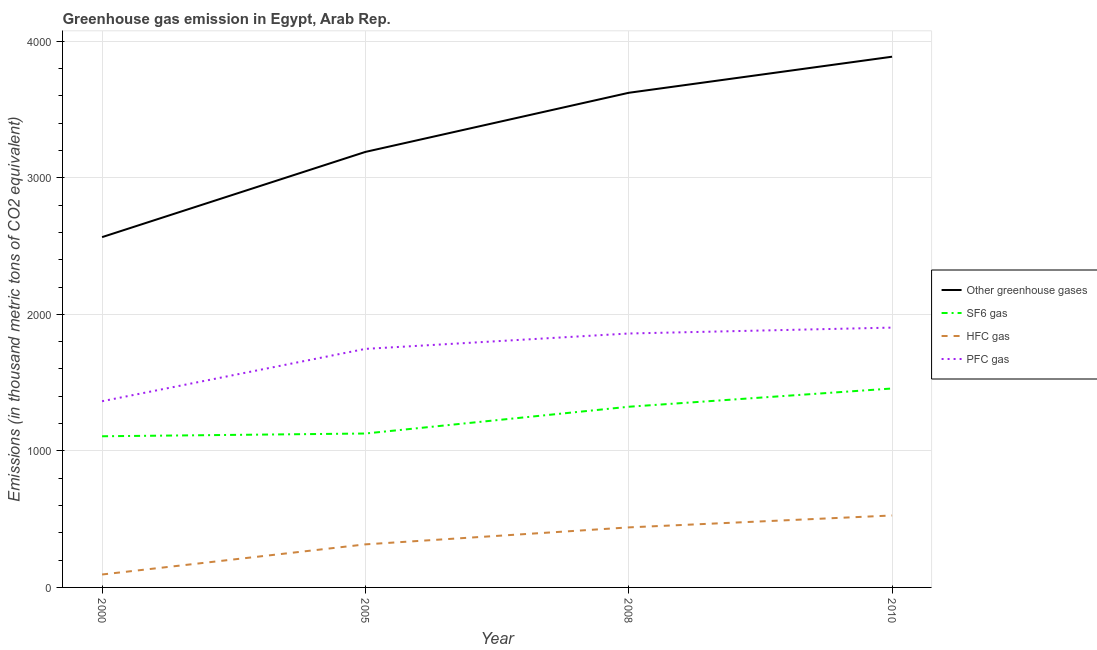Does the line corresponding to emission of pfc gas intersect with the line corresponding to emission of sf6 gas?
Your answer should be very brief. No. Is the number of lines equal to the number of legend labels?
Make the answer very short. Yes. What is the emission of hfc gas in 2000?
Give a very brief answer. 94.7. Across all years, what is the maximum emission of sf6 gas?
Make the answer very short. 1457. Across all years, what is the minimum emission of pfc gas?
Offer a terse response. 1363.8. In which year was the emission of pfc gas maximum?
Offer a very short reply. 2010. In which year was the emission of pfc gas minimum?
Your response must be concise. 2000. What is the total emission of hfc gas in the graph?
Offer a very short reply. 1376.8. What is the difference between the emission of pfc gas in 2000 and that in 2005?
Give a very brief answer. -383.3. What is the difference between the emission of pfc gas in 2010 and the emission of sf6 gas in 2008?
Ensure brevity in your answer.  579.7. What is the average emission of pfc gas per year?
Provide a succinct answer. 1718.42. In the year 2000, what is the difference between the emission of greenhouse gases and emission of pfc gas?
Your response must be concise. 1201.8. In how many years, is the emission of hfc gas greater than 600 thousand metric tons?
Your response must be concise. 0. What is the ratio of the emission of greenhouse gases in 2005 to that in 2010?
Make the answer very short. 0.82. Is the emission of sf6 gas in 2008 less than that in 2010?
Give a very brief answer. Yes. What is the difference between the highest and the second highest emission of hfc gas?
Make the answer very short. 87.3. What is the difference between the highest and the lowest emission of pfc gas?
Offer a very short reply. 539.2. Is the sum of the emission of hfc gas in 2000 and 2010 greater than the maximum emission of greenhouse gases across all years?
Make the answer very short. No. Is it the case that in every year, the sum of the emission of greenhouse gases and emission of sf6 gas is greater than the emission of hfc gas?
Provide a succinct answer. Yes. Is the emission of greenhouse gases strictly greater than the emission of sf6 gas over the years?
Offer a very short reply. Yes. What is the difference between two consecutive major ticks on the Y-axis?
Make the answer very short. 1000. Does the graph contain any zero values?
Provide a short and direct response. No. What is the title of the graph?
Your response must be concise. Greenhouse gas emission in Egypt, Arab Rep. What is the label or title of the Y-axis?
Your response must be concise. Emissions (in thousand metric tons of CO2 equivalent). What is the Emissions (in thousand metric tons of CO2 equivalent) of Other greenhouse gases in 2000?
Keep it short and to the point. 2565.6. What is the Emissions (in thousand metric tons of CO2 equivalent) of SF6 gas in 2000?
Give a very brief answer. 1107.1. What is the Emissions (in thousand metric tons of CO2 equivalent) of HFC gas in 2000?
Make the answer very short. 94.7. What is the Emissions (in thousand metric tons of CO2 equivalent) of PFC gas in 2000?
Offer a terse response. 1363.8. What is the Emissions (in thousand metric tons of CO2 equivalent) of Other greenhouse gases in 2005?
Your answer should be very brief. 3189.8. What is the Emissions (in thousand metric tons of CO2 equivalent) of SF6 gas in 2005?
Provide a short and direct response. 1127.3. What is the Emissions (in thousand metric tons of CO2 equivalent) in HFC gas in 2005?
Your answer should be compact. 315.4. What is the Emissions (in thousand metric tons of CO2 equivalent) of PFC gas in 2005?
Ensure brevity in your answer.  1747.1. What is the Emissions (in thousand metric tons of CO2 equivalent) of Other greenhouse gases in 2008?
Your answer should be compact. 3622.8. What is the Emissions (in thousand metric tons of CO2 equivalent) in SF6 gas in 2008?
Give a very brief answer. 1323.3. What is the Emissions (in thousand metric tons of CO2 equivalent) in HFC gas in 2008?
Offer a very short reply. 439.7. What is the Emissions (in thousand metric tons of CO2 equivalent) in PFC gas in 2008?
Offer a very short reply. 1859.8. What is the Emissions (in thousand metric tons of CO2 equivalent) of Other greenhouse gases in 2010?
Your response must be concise. 3887. What is the Emissions (in thousand metric tons of CO2 equivalent) in SF6 gas in 2010?
Your answer should be compact. 1457. What is the Emissions (in thousand metric tons of CO2 equivalent) of HFC gas in 2010?
Your response must be concise. 527. What is the Emissions (in thousand metric tons of CO2 equivalent) in PFC gas in 2010?
Provide a succinct answer. 1903. Across all years, what is the maximum Emissions (in thousand metric tons of CO2 equivalent) in Other greenhouse gases?
Offer a terse response. 3887. Across all years, what is the maximum Emissions (in thousand metric tons of CO2 equivalent) of SF6 gas?
Your answer should be compact. 1457. Across all years, what is the maximum Emissions (in thousand metric tons of CO2 equivalent) in HFC gas?
Offer a very short reply. 527. Across all years, what is the maximum Emissions (in thousand metric tons of CO2 equivalent) in PFC gas?
Keep it short and to the point. 1903. Across all years, what is the minimum Emissions (in thousand metric tons of CO2 equivalent) of Other greenhouse gases?
Your answer should be very brief. 2565.6. Across all years, what is the minimum Emissions (in thousand metric tons of CO2 equivalent) in SF6 gas?
Provide a short and direct response. 1107.1. Across all years, what is the minimum Emissions (in thousand metric tons of CO2 equivalent) in HFC gas?
Your answer should be very brief. 94.7. Across all years, what is the minimum Emissions (in thousand metric tons of CO2 equivalent) in PFC gas?
Offer a very short reply. 1363.8. What is the total Emissions (in thousand metric tons of CO2 equivalent) of Other greenhouse gases in the graph?
Offer a terse response. 1.33e+04. What is the total Emissions (in thousand metric tons of CO2 equivalent) of SF6 gas in the graph?
Ensure brevity in your answer.  5014.7. What is the total Emissions (in thousand metric tons of CO2 equivalent) in HFC gas in the graph?
Offer a very short reply. 1376.8. What is the total Emissions (in thousand metric tons of CO2 equivalent) in PFC gas in the graph?
Provide a succinct answer. 6873.7. What is the difference between the Emissions (in thousand metric tons of CO2 equivalent) in Other greenhouse gases in 2000 and that in 2005?
Keep it short and to the point. -624.2. What is the difference between the Emissions (in thousand metric tons of CO2 equivalent) of SF6 gas in 2000 and that in 2005?
Offer a very short reply. -20.2. What is the difference between the Emissions (in thousand metric tons of CO2 equivalent) of HFC gas in 2000 and that in 2005?
Your answer should be very brief. -220.7. What is the difference between the Emissions (in thousand metric tons of CO2 equivalent) in PFC gas in 2000 and that in 2005?
Keep it short and to the point. -383.3. What is the difference between the Emissions (in thousand metric tons of CO2 equivalent) of Other greenhouse gases in 2000 and that in 2008?
Keep it short and to the point. -1057.2. What is the difference between the Emissions (in thousand metric tons of CO2 equivalent) of SF6 gas in 2000 and that in 2008?
Your response must be concise. -216.2. What is the difference between the Emissions (in thousand metric tons of CO2 equivalent) in HFC gas in 2000 and that in 2008?
Your answer should be compact. -345. What is the difference between the Emissions (in thousand metric tons of CO2 equivalent) in PFC gas in 2000 and that in 2008?
Keep it short and to the point. -496. What is the difference between the Emissions (in thousand metric tons of CO2 equivalent) in Other greenhouse gases in 2000 and that in 2010?
Your answer should be compact. -1321.4. What is the difference between the Emissions (in thousand metric tons of CO2 equivalent) in SF6 gas in 2000 and that in 2010?
Offer a terse response. -349.9. What is the difference between the Emissions (in thousand metric tons of CO2 equivalent) of HFC gas in 2000 and that in 2010?
Your response must be concise. -432.3. What is the difference between the Emissions (in thousand metric tons of CO2 equivalent) of PFC gas in 2000 and that in 2010?
Provide a short and direct response. -539.2. What is the difference between the Emissions (in thousand metric tons of CO2 equivalent) of Other greenhouse gases in 2005 and that in 2008?
Provide a succinct answer. -433. What is the difference between the Emissions (in thousand metric tons of CO2 equivalent) of SF6 gas in 2005 and that in 2008?
Provide a short and direct response. -196. What is the difference between the Emissions (in thousand metric tons of CO2 equivalent) of HFC gas in 2005 and that in 2008?
Offer a very short reply. -124.3. What is the difference between the Emissions (in thousand metric tons of CO2 equivalent) of PFC gas in 2005 and that in 2008?
Your answer should be very brief. -112.7. What is the difference between the Emissions (in thousand metric tons of CO2 equivalent) in Other greenhouse gases in 2005 and that in 2010?
Offer a terse response. -697.2. What is the difference between the Emissions (in thousand metric tons of CO2 equivalent) of SF6 gas in 2005 and that in 2010?
Your answer should be very brief. -329.7. What is the difference between the Emissions (in thousand metric tons of CO2 equivalent) of HFC gas in 2005 and that in 2010?
Provide a succinct answer. -211.6. What is the difference between the Emissions (in thousand metric tons of CO2 equivalent) in PFC gas in 2005 and that in 2010?
Make the answer very short. -155.9. What is the difference between the Emissions (in thousand metric tons of CO2 equivalent) in Other greenhouse gases in 2008 and that in 2010?
Provide a succinct answer. -264.2. What is the difference between the Emissions (in thousand metric tons of CO2 equivalent) in SF6 gas in 2008 and that in 2010?
Your answer should be compact. -133.7. What is the difference between the Emissions (in thousand metric tons of CO2 equivalent) of HFC gas in 2008 and that in 2010?
Provide a short and direct response. -87.3. What is the difference between the Emissions (in thousand metric tons of CO2 equivalent) in PFC gas in 2008 and that in 2010?
Your answer should be compact. -43.2. What is the difference between the Emissions (in thousand metric tons of CO2 equivalent) in Other greenhouse gases in 2000 and the Emissions (in thousand metric tons of CO2 equivalent) in SF6 gas in 2005?
Offer a very short reply. 1438.3. What is the difference between the Emissions (in thousand metric tons of CO2 equivalent) in Other greenhouse gases in 2000 and the Emissions (in thousand metric tons of CO2 equivalent) in HFC gas in 2005?
Offer a terse response. 2250.2. What is the difference between the Emissions (in thousand metric tons of CO2 equivalent) in Other greenhouse gases in 2000 and the Emissions (in thousand metric tons of CO2 equivalent) in PFC gas in 2005?
Offer a terse response. 818.5. What is the difference between the Emissions (in thousand metric tons of CO2 equivalent) of SF6 gas in 2000 and the Emissions (in thousand metric tons of CO2 equivalent) of HFC gas in 2005?
Your response must be concise. 791.7. What is the difference between the Emissions (in thousand metric tons of CO2 equivalent) in SF6 gas in 2000 and the Emissions (in thousand metric tons of CO2 equivalent) in PFC gas in 2005?
Your response must be concise. -640. What is the difference between the Emissions (in thousand metric tons of CO2 equivalent) of HFC gas in 2000 and the Emissions (in thousand metric tons of CO2 equivalent) of PFC gas in 2005?
Offer a very short reply. -1652.4. What is the difference between the Emissions (in thousand metric tons of CO2 equivalent) of Other greenhouse gases in 2000 and the Emissions (in thousand metric tons of CO2 equivalent) of SF6 gas in 2008?
Your answer should be very brief. 1242.3. What is the difference between the Emissions (in thousand metric tons of CO2 equivalent) in Other greenhouse gases in 2000 and the Emissions (in thousand metric tons of CO2 equivalent) in HFC gas in 2008?
Give a very brief answer. 2125.9. What is the difference between the Emissions (in thousand metric tons of CO2 equivalent) of Other greenhouse gases in 2000 and the Emissions (in thousand metric tons of CO2 equivalent) of PFC gas in 2008?
Your answer should be compact. 705.8. What is the difference between the Emissions (in thousand metric tons of CO2 equivalent) of SF6 gas in 2000 and the Emissions (in thousand metric tons of CO2 equivalent) of HFC gas in 2008?
Offer a very short reply. 667.4. What is the difference between the Emissions (in thousand metric tons of CO2 equivalent) in SF6 gas in 2000 and the Emissions (in thousand metric tons of CO2 equivalent) in PFC gas in 2008?
Make the answer very short. -752.7. What is the difference between the Emissions (in thousand metric tons of CO2 equivalent) in HFC gas in 2000 and the Emissions (in thousand metric tons of CO2 equivalent) in PFC gas in 2008?
Your answer should be very brief. -1765.1. What is the difference between the Emissions (in thousand metric tons of CO2 equivalent) in Other greenhouse gases in 2000 and the Emissions (in thousand metric tons of CO2 equivalent) in SF6 gas in 2010?
Offer a terse response. 1108.6. What is the difference between the Emissions (in thousand metric tons of CO2 equivalent) of Other greenhouse gases in 2000 and the Emissions (in thousand metric tons of CO2 equivalent) of HFC gas in 2010?
Provide a succinct answer. 2038.6. What is the difference between the Emissions (in thousand metric tons of CO2 equivalent) of Other greenhouse gases in 2000 and the Emissions (in thousand metric tons of CO2 equivalent) of PFC gas in 2010?
Offer a very short reply. 662.6. What is the difference between the Emissions (in thousand metric tons of CO2 equivalent) in SF6 gas in 2000 and the Emissions (in thousand metric tons of CO2 equivalent) in HFC gas in 2010?
Ensure brevity in your answer.  580.1. What is the difference between the Emissions (in thousand metric tons of CO2 equivalent) in SF6 gas in 2000 and the Emissions (in thousand metric tons of CO2 equivalent) in PFC gas in 2010?
Make the answer very short. -795.9. What is the difference between the Emissions (in thousand metric tons of CO2 equivalent) of HFC gas in 2000 and the Emissions (in thousand metric tons of CO2 equivalent) of PFC gas in 2010?
Provide a succinct answer. -1808.3. What is the difference between the Emissions (in thousand metric tons of CO2 equivalent) in Other greenhouse gases in 2005 and the Emissions (in thousand metric tons of CO2 equivalent) in SF6 gas in 2008?
Your answer should be compact. 1866.5. What is the difference between the Emissions (in thousand metric tons of CO2 equivalent) of Other greenhouse gases in 2005 and the Emissions (in thousand metric tons of CO2 equivalent) of HFC gas in 2008?
Keep it short and to the point. 2750.1. What is the difference between the Emissions (in thousand metric tons of CO2 equivalent) of Other greenhouse gases in 2005 and the Emissions (in thousand metric tons of CO2 equivalent) of PFC gas in 2008?
Your response must be concise. 1330. What is the difference between the Emissions (in thousand metric tons of CO2 equivalent) of SF6 gas in 2005 and the Emissions (in thousand metric tons of CO2 equivalent) of HFC gas in 2008?
Ensure brevity in your answer.  687.6. What is the difference between the Emissions (in thousand metric tons of CO2 equivalent) in SF6 gas in 2005 and the Emissions (in thousand metric tons of CO2 equivalent) in PFC gas in 2008?
Ensure brevity in your answer.  -732.5. What is the difference between the Emissions (in thousand metric tons of CO2 equivalent) in HFC gas in 2005 and the Emissions (in thousand metric tons of CO2 equivalent) in PFC gas in 2008?
Your response must be concise. -1544.4. What is the difference between the Emissions (in thousand metric tons of CO2 equivalent) in Other greenhouse gases in 2005 and the Emissions (in thousand metric tons of CO2 equivalent) in SF6 gas in 2010?
Make the answer very short. 1732.8. What is the difference between the Emissions (in thousand metric tons of CO2 equivalent) in Other greenhouse gases in 2005 and the Emissions (in thousand metric tons of CO2 equivalent) in HFC gas in 2010?
Provide a succinct answer. 2662.8. What is the difference between the Emissions (in thousand metric tons of CO2 equivalent) in Other greenhouse gases in 2005 and the Emissions (in thousand metric tons of CO2 equivalent) in PFC gas in 2010?
Provide a succinct answer. 1286.8. What is the difference between the Emissions (in thousand metric tons of CO2 equivalent) in SF6 gas in 2005 and the Emissions (in thousand metric tons of CO2 equivalent) in HFC gas in 2010?
Offer a very short reply. 600.3. What is the difference between the Emissions (in thousand metric tons of CO2 equivalent) of SF6 gas in 2005 and the Emissions (in thousand metric tons of CO2 equivalent) of PFC gas in 2010?
Offer a terse response. -775.7. What is the difference between the Emissions (in thousand metric tons of CO2 equivalent) of HFC gas in 2005 and the Emissions (in thousand metric tons of CO2 equivalent) of PFC gas in 2010?
Your answer should be compact. -1587.6. What is the difference between the Emissions (in thousand metric tons of CO2 equivalent) of Other greenhouse gases in 2008 and the Emissions (in thousand metric tons of CO2 equivalent) of SF6 gas in 2010?
Provide a succinct answer. 2165.8. What is the difference between the Emissions (in thousand metric tons of CO2 equivalent) in Other greenhouse gases in 2008 and the Emissions (in thousand metric tons of CO2 equivalent) in HFC gas in 2010?
Keep it short and to the point. 3095.8. What is the difference between the Emissions (in thousand metric tons of CO2 equivalent) of Other greenhouse gases in 2008 and the Emissions (in thousand metric tons of CO2 equivalent) of PFC gas in 2010?
Ensure brevity in your answer.  1719.8. What is the difference between the Emissions (in thousand metric tons of CO2 equivalent) of SF6 gas in 2008 and the Emissions (in thousand metric tons of CO2 equivalent) of HFC gas in 2010?
Provide a succinct answer. 796.3. What is the difference between the Emissions (in thousand metric tons of CO2 equivalent) of SF6 gas in 2008 and the Emissions (in thousand metric tons of CO2 equivalent) of PFC gas in 2010?
Keep it short and to the point. -579.7. What is the difference between the Emissions (in thousand metric tons of CO2 equivalent) in HFC gas in 2008 and the Emissions (in thousand metric tons of CO2 equivalent) in PFC gas in 2010?
Make the answer very short. -1463.3. What is the average Emissions (in thousand metric tons of CO2 equivalent) of Other greenhouse gases per year?
Offer a very short reply. 3316.3. What is the average Emissions (in thousand metric tons of CO2 equivalent) in SF6 gas per year?
Offer a very short reply. 1253.67. What is the average Emissions (in thousand metric tons of CO2 equivalent) in HFC gas per year?
Make the answer very short. 344.2. What is the average Emissions (in thousand metric tons of CO2 equivalent) in PFC gas per year?
Give a very brief answer. 1718.42. In the year 2000, what is the difference between the Emissions (in thousand metric tons of CO2 equivalent) of Other greenhouse gases and Emissions (in thousand metric tons of CO2 equivalent) of SF6 gas?
Offer a terse response. 1458.5. In the year 2000, what is the difference between the Emissions (in thousand metric tons of CO2 equivalent) of Other greenhouse gases and Emissions (in thousand metric tons of CO2 equivalent) of HFC gas?
Offer a very short reply. 2470.9. In the year 2000, what is the difference between the Emissions (in thousand metric tons of CO2 equivalent) of Other greenhouse gases and Emissions (in thousand metric tons of CO2 equivalent) of PFC gas?
Offer a terse response. 1201.8. In the year 2000, what is the difference between the Emissions (in thousand metric tons of CO2 equivalent) of SF6 gas and Emissions (in thousand metric tons of CO2 equivalent) of HFC gas?
Keep it short and to the point. 1012.4. In the year 2000, what is the difference between the Emissions (in thousand metric tons of CO2 equivalent) in SF6 gas and Emissions (in thousand metric tons of CO2 equivalent) in PFC gas?
Provide a short and direct response. -256.7. In the year 2000, what is the difference between the Emissions (in thousand metric tons of CO2 equivalent) in HFC gas and Emissions (in thousand metric tons of CO2 equivalent) in PFC gas?
Make the answer very short. -1269.1. In the year 2005, what is the difference between the Emissions (in thousand metric tons of CO2 equivalent) of Other greenhouse gases and Emissions (in thousand metric tons of CO2 equivalent) of SF6 gas?
Offer a very short reply. 2062.5. In the year 2005, what is the difference between the Emissions (in thousand metric tons of CO2 equivalent) in Other greenhouse gases and Emissions (in thousand metric tons of CO2 equivalent) in HFC gas?
Provide a short and direct response. 2874.4. In the year 2005, what is the difference between the Emissions (in thousand metric tons of CO2 equivalent) of Other greenhouse gases and Emissions (in thousand metric tons of CO2 equivalent) of PFC gas?
Your answer should be very brief. 1442.7. In the year 2005, what is the difference between the Emissions (in thousand metric tons of CO2 equivalent) of SF6 gas and Emissions (in thousand metric tons of CO2 equivalent) of HFC gas?
Provide a succinct answer. 811.9. In the year 2005, what is the difference between the Emissions (in thousand metric tons of CO2 equivalent) in SF6 gas and Emissions (in thousand metric tons of CO2 equivalent) in PFC gas?
Ensure brevity in your answer.  -619.8. In the year 2005, what is the difference between the Emissions (in thousand metric tons of CO2 equivalent) of HFC gas and Emissions (in thousand metric tons of CO2 equivalent) of PFC gas?
Give a very brief answer. -1431.7. In the year 2008, what is the difference between the Emissions (in thousand metric tons of CO2 equivalent) of Other greenhouse gases and Emissions (in thousand metric tons of CO2 equivalent) of SF6 gas?
Keep it short and to the point. 2299.5. In the year 2008, what is the difference between the Emissions (in thousand metric tons of CO2 equivalent) in Other greenhouse gases and Emissions (in thousand metric tons of CO2 equivalent) in HFC gas?
Your answer should be compact. 3183.1. In the year 2008, what is the difference between the Emissions (in thousand metric tons of CO2 equivalent) in Other greenhouse gases and Emissions (in thousand metric tons of CO2 equivalent) in PFC gas?
Provide a succinct answer. 1763. In the year 2008, what is the difference between the Emissions (in thousand metric tons of CO2 equivalent) of SF6 gas and Emissions (in thousand metric tons of CO2 equivalent) of HFC gas?
Keep it short and to the point. 883.6. In the year 2008, what is the difference between the Emissions (in thousand metric tons of CO2 equivalent) in SF6 gas and Emissions (in thousand metric tons of CO2 equivalent) in PFC gas?
Give a very brief answer. -536.5. In the year 2008, what is the difference between the Emissions (in thousand metric tons of CO2 equivalent) in HFC gas and Emissions (in thousand metric tons of CO2 equivalent) in PFC gas?
Your response must be concise. -1420.1. In the year 2010, what is the difference between the Emissions (in thousand metric tons of CO2 equivalent) of Other greenhouse gases and Emissions (in thousand metric tons of CO2 equivalent) of SF6 gas?
Your response must be concise. 2430. In the year 2010, what is the difference between the Emissions (in thousand metric tons of CO2 equivalent) in Other greenhouse gases and Emissions (in thousand metric tons of CO2 equivalent) in HFC gas?
Keep it short and to the point. 3360. In the year 2010, what is the difference between the Emissions (in thousand metric tons of CO2 equivalent) of Other greenhouse gases and Emissions (in thousand metric tons of CO2 equivalent) of PFC gas?
Your answer should be compact. 1984. In the year 2010, what is the difference between the Emissions (in thousand metric tons of CO2 equivalent) in SF6 gas and Emissions (in thousand metric tons of CO2 equivalent) in HFC gas?
Give a very brief answer. 930. In the year 2010, what is the difference between the Emissions (in thousand metric tons of CO2 equivalent) of SF6 gas and Emissions (in thousand metric tons of CO2 equivalent) of PFC gas?
Make the answer very short. -446. In the year 2010, what is the difference between the Emissions (in thousand metric tons of CO2 equivalent) in HFC gas and Emissions (in thousand metric tons of CO2 equivalent) in PFC gas?
Ensure brevity in your answer.  -1376. What is the ratio of the Emissions (in thousand metric tons of CO2 equivalent) of Other greenhouse gases in 2000 to that in 2005?
Your answer should be compact. 0.8. What is the ratio of the Emissions (in thousand metric tons of CO2 equivalent) of SF6 gas in 2000 to that in 2005?
Provide a succinct answer. 0.98. What is the ratio of the Emissions (in thousand metric tons of CO2 equivalent) of HFC gas in 2000 to that in 2005?
Keep it short and to the point. 0.3. What is the ratio of the Emissions (in thousand metric tons of CO2 equivalent) of PFC gas in 2000 to that in 2005?
Keep it short and to the point. 0.78. What is the ratio of the Emissions (in thousand metric tons of CO2 equivalent) in Other greenhouse gases in 2000 to that in 2008?
Provide a succinct answer. 0.71. What is the ratio of the Emissions (in thousand metric tons of CO2 equivalent) in SF6 gas in 2000 to that in 2008?
Provide a short and direct response. 0.84. What is the ratio of the Emissions (in thousand metric tons of CO2 equivalent) of HFC gas in 2000 to that in 2008?
Provide a succinct answer. 0.22. What is the ratio of the Emissions (in thousand metric tons of CO2 equivalent) of PFC gas in 2000 to that in 2008?
Keep it short and to the point. 0.73. What is the ratio of the Emissions (in thousand metric tons of CO2 equivalent) in Other greenhouse gases in 2000 to that in 2010?
Provide a succinct answer. 0.66. What is the ratio of the Emissions (in thousand metric tons of CO2 equivalent) in SF6 gas in 2000 to that in 2010?
Offer a terse response. 0.76. What is the ratio of the Emissions (in thousand metric tons of CO2 equivalent) in HFC gas in 2000 to that in 2010?
Provide a short and direct response. 0.18. What is the ratio of the Emissions (in thousand metric tons of CO2 equivalent) in PFC gas in 2000 to that in 2010?
Keep it short and to the point. 0.72. What is the ratio of the Emissions (in thousand metric tons of CO2 equivalent) in Other greenhouse gases in 2005 to that in 2008?
Offer a very short reply. 0.88. What is the ratio of the Emissions (in thousand metric tons of CO2 equivalent) in SF6 gas in 2005 to that in 2008?
Offer a terse response. 0.85. What is the ratio of the Emissions (in thousand metric tons of CO2 equivalent) of HFC gas in 2005 to that in 2008?
Give a very brief answer. 0.72. What is the ratio of the Emissions (in thousand metric tons of CO2 equivalent) in PFC gas in 2005 to that in 2008?
Your answer should be compact. 0.94. What is the ratio of the Emissions (in thousand metric tons of CO2 equivalent) in Other greenhouse gases in 2005 to that in 2010?
Provide a succinct answer. 0.82. What is the ratio of the Emissions (in thousand metric tons of CO2 equivalent) in SF6 gas in 2005 to that in 2010?
Give a very brief answer. 0.77. What is the ratio of the Emissions (in thousand metric tons of CO2 equivalent) in HFC gas in 2005 to that in 2010?
Offer a terse response. 0.6. What is the ratio of the Emissions (in thousand metric tons of CO2 equivalent) of PFC gas in 2005 to that in 2010?
Offer a very short reply. 0.92. What is the ratio of the Emissions (in thousand metric tons of CO2 equivalent) in Other greenhouse gases in 2008 to that in 2010?
Your answer should be very brief. 0.93. What is the ratio of the Emissions (in thousand metric tons of CO2 equivalent) of SF6 gas in 2008 to that in 2010?
Your answer should be very brief. 0.91. What is the ratio of the Emissions (in thousand metric tons of CO2 equivalent) in HFC gas in 2008 to that in 2010?
Your response must be concise. 0.83. What is the ratio of the Emissions (in thousand metric tons of CO2 equivalent) of PFC gas in 2008 to that in 2010?
Provide a succinct answer. 0.98. What is the difference between the highest and the second highest Emissions (in thousand metric tons of CO2 equivalent) in Other greenhouse gases?
Provide a succinct answer. 264.2. What is the difference between the highest and the second highest Emissions (in thousand metric tons of CO2 equivalent) in SF6 gas?
Your response must be concise. 133.7. What is the difference between the highest and the second highest Emissions (in thousand metric tons of CO2 equivalent) in HFC gas?
Offer a very short reply. 87.3. What is the difference between the highest and the second highest Emissions (in thousand metric tons of CO2 equivalent) in PFC gas?
Ensure brevity in your answer.  43.2. What is the difference between the highest and the lowest Emissions (in thousand metric tons of CO2 equivalent) in Other greenhouse gases?
Provide a succinct answer. 1321.4. What is the difference between the highest and the lowest Emissions (in thousand metric tons of CO2 equivalent) in SF6 gas?
Give a very brief answer. 349.9. What is the difference between the highest and the lowest Emissions (in thousand metric tons of CO2 equivalent) in HFC gas?
Offer a terse response. 432.3. What is the difference between the highest and the lowest Emissions (in thousand metric tons of CO2 equivalent) of PFC gas?
Offer a very short reply. 539.2. 